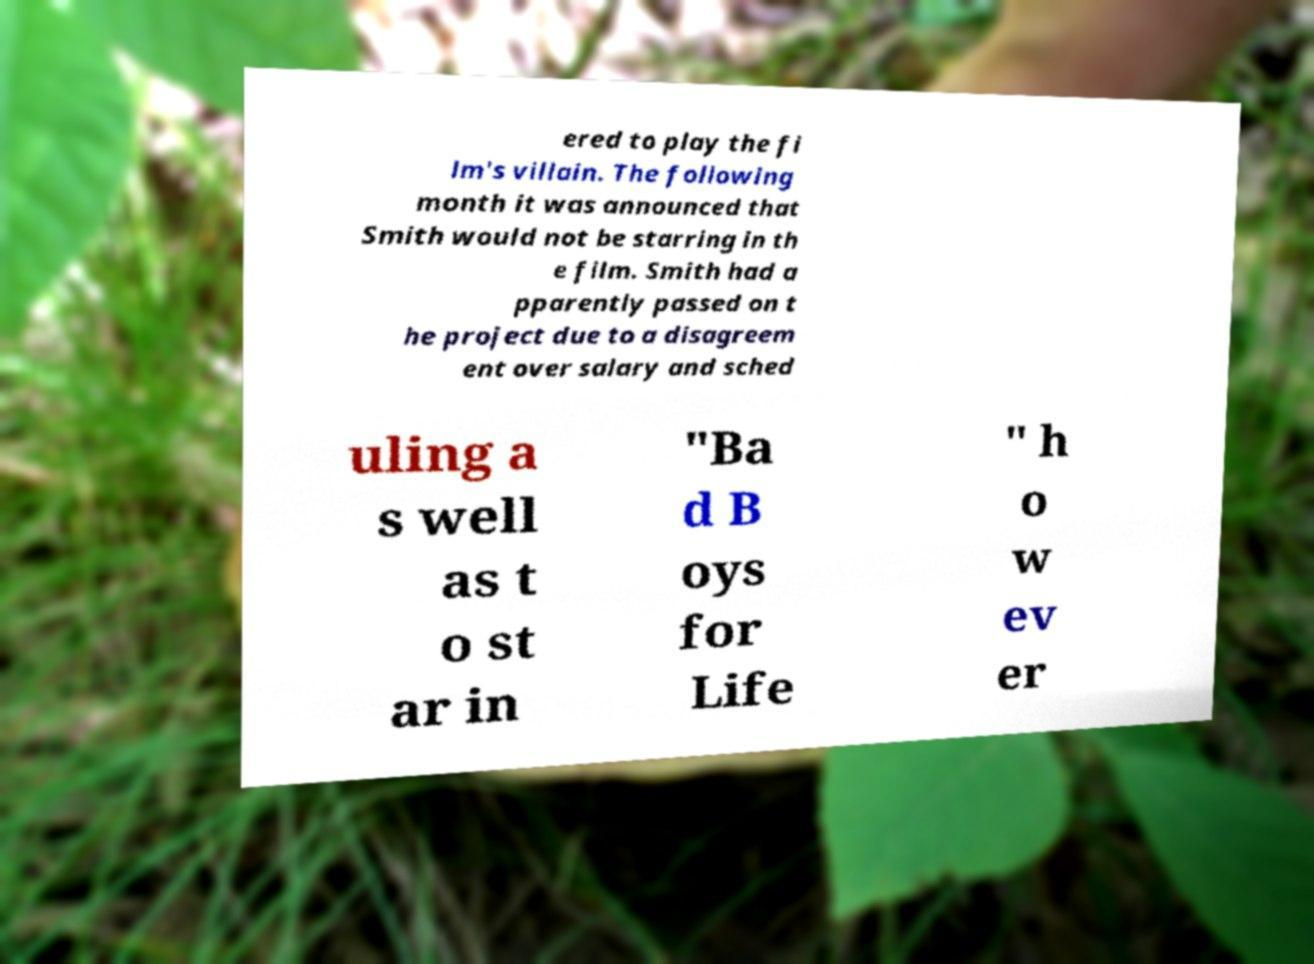Could you extract and type out the text from this image? ered to play the fi lm's villain. The following month it was announced that Smith would not be starring in th e film. Smith had a pparently passed on t he project due to a disagreem ent over salary and sched uling a s well as t o st ar in "Ba d B oys for Life " h o w ev er 